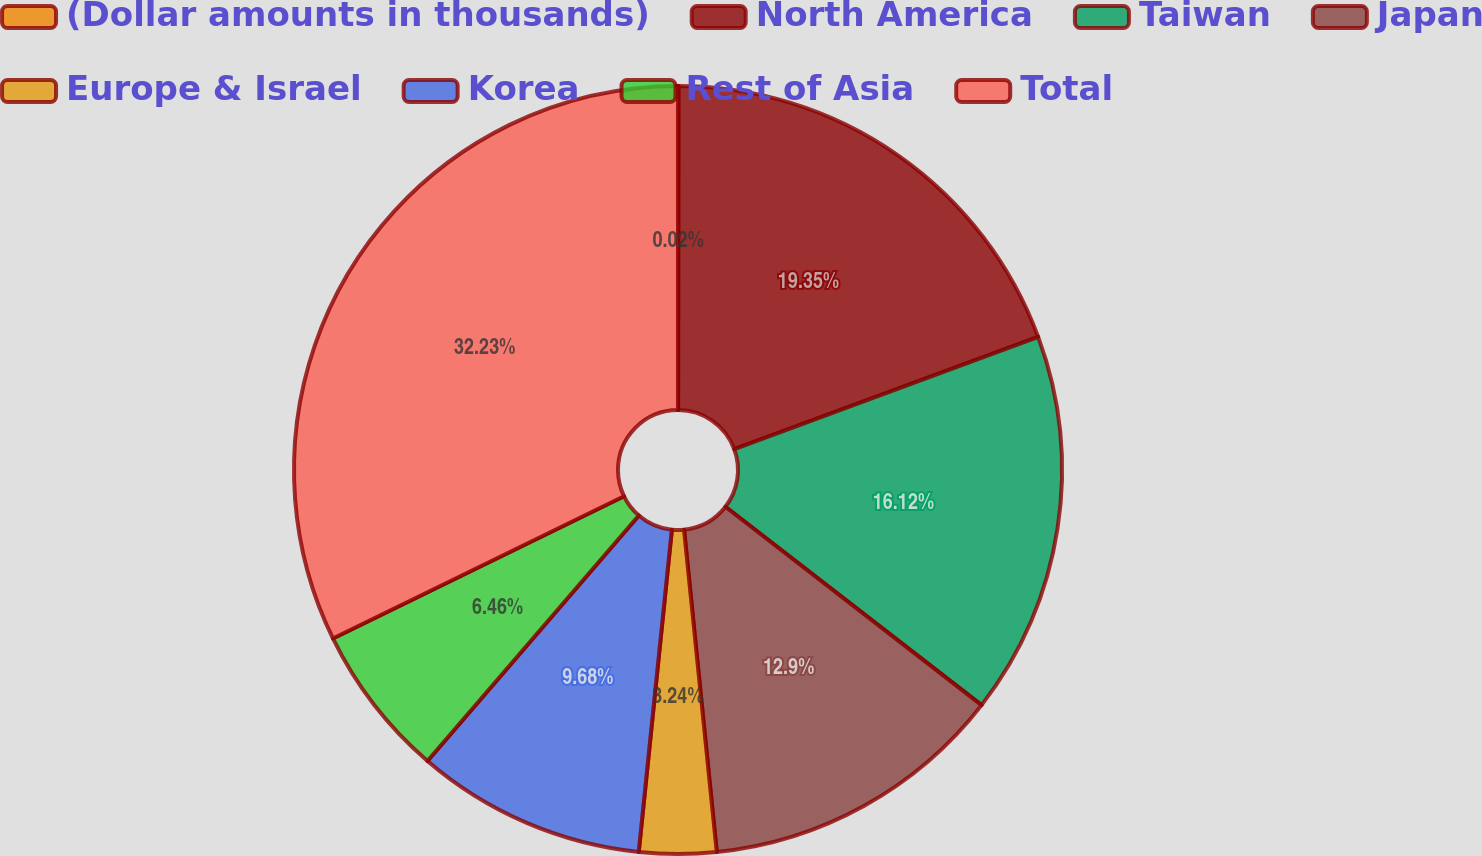Convert chart. <chart><loc_0><loc_0><loc_500><loc_500><pie_chart><fcel>(Dollar amounts in thousands)<fcel>North America<fcel>Taiwan<fcel>Japan<fcel>Europe & Israel<fcel>Korea<fcel>Rest of Asia<fcel>Total<nl><fcel>0.02%<fcel>19.34%<fcel>16.12%<fcel>12.9%<fcel>3.24%<fcel>9.68%<fcel>6.46%<fcel>32.22%<nl></chart> 